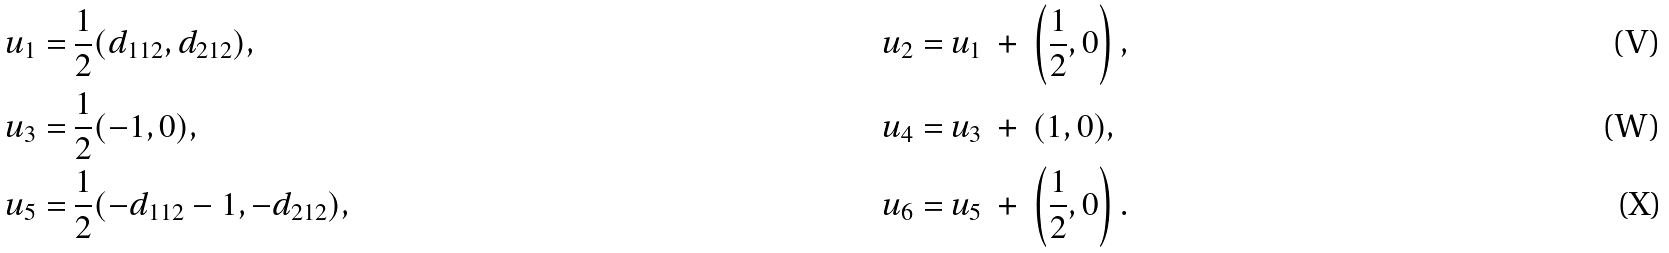<formula> <loc_0><loc_0><loc_500><loc_500>u _ { 1 } = & \ \frac { 1 } { 2 } ( d _ { 1 1 2 } , d _ { 2 1 2 } ) , & u _ { 2 } = & \ u _ { 1 } \ + \ \left ( \frac { 1 } { 2 } , 0 \right ) , \\ u _ { 3 } = & \ \frac { 1 } { 2 } ( - 1 , 0 ) , & u _ { 4 } = & \ u _ { 3 } \ + \ ( 1 , 0 ) , \\ u _ { 5 } = & \ \frac { 1 } { 2 } ( - d _ { 1 1 2 } - 1 , - d _ { 2 1 2 } ) , & u _ { 6 } = & \ u _ { 5 } \ + \ \left ( \frac { 1 } { 2 } , 0 \right ) .</formula> 